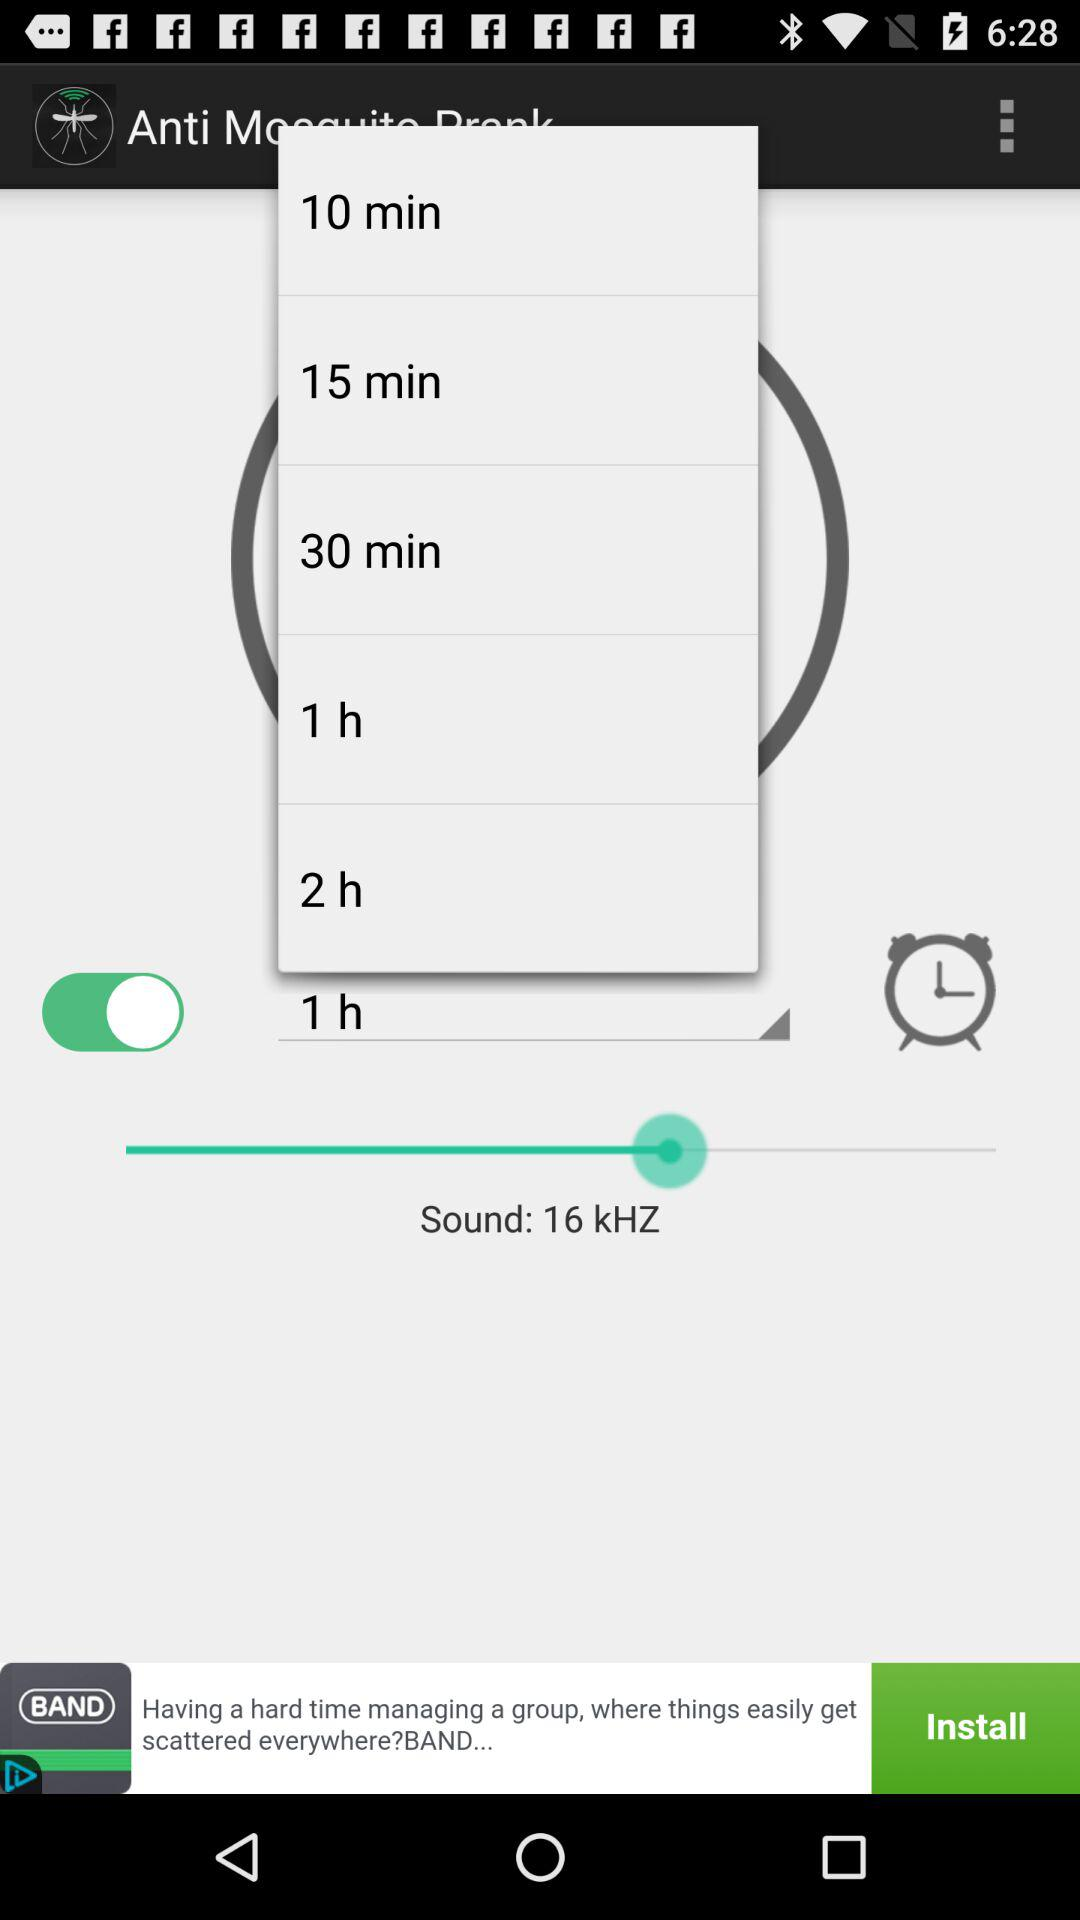What is the status of the alarm? The status of the alarm is on. 